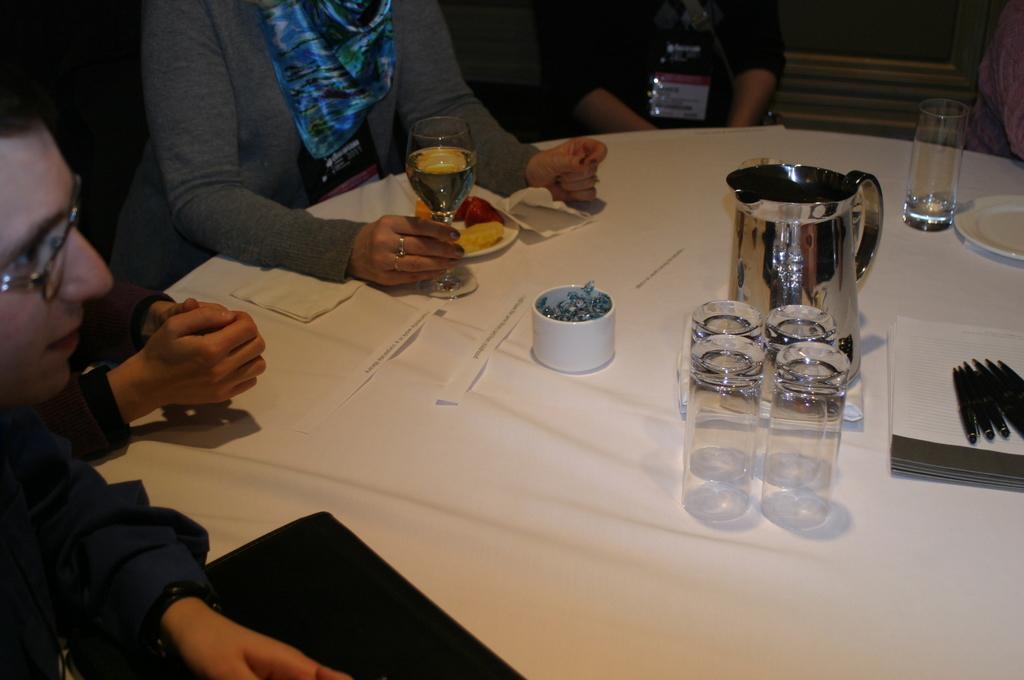Please provide a concise description of this image. In this picture there is a man to the right and a person sitting beside him holding a wine glass in her right hand the plate and in front of her with food and also there are some water glasses and water jar on the table. 